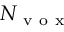<formula> <loc_0><loc_0><loc_500><loc_500>N _ { v o x }</formula> 